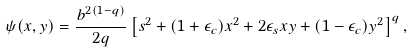Convert formula to latex. <formula><loc_0><loc_0><loc_500><loc_500>\psi ( x , y ) = \frac { b ^ { 2 ( 1 - q ) } } { 2 q } \left [ s ^ { 2 } + ( 1 + \epsilon _ { c } ) x ^ { 2 } + 2 \epsilon _ { s } x y + ( 1 - \epsilon _ { c } ) y ^ { 2 } \right ] ^ { q } ,</formula> 